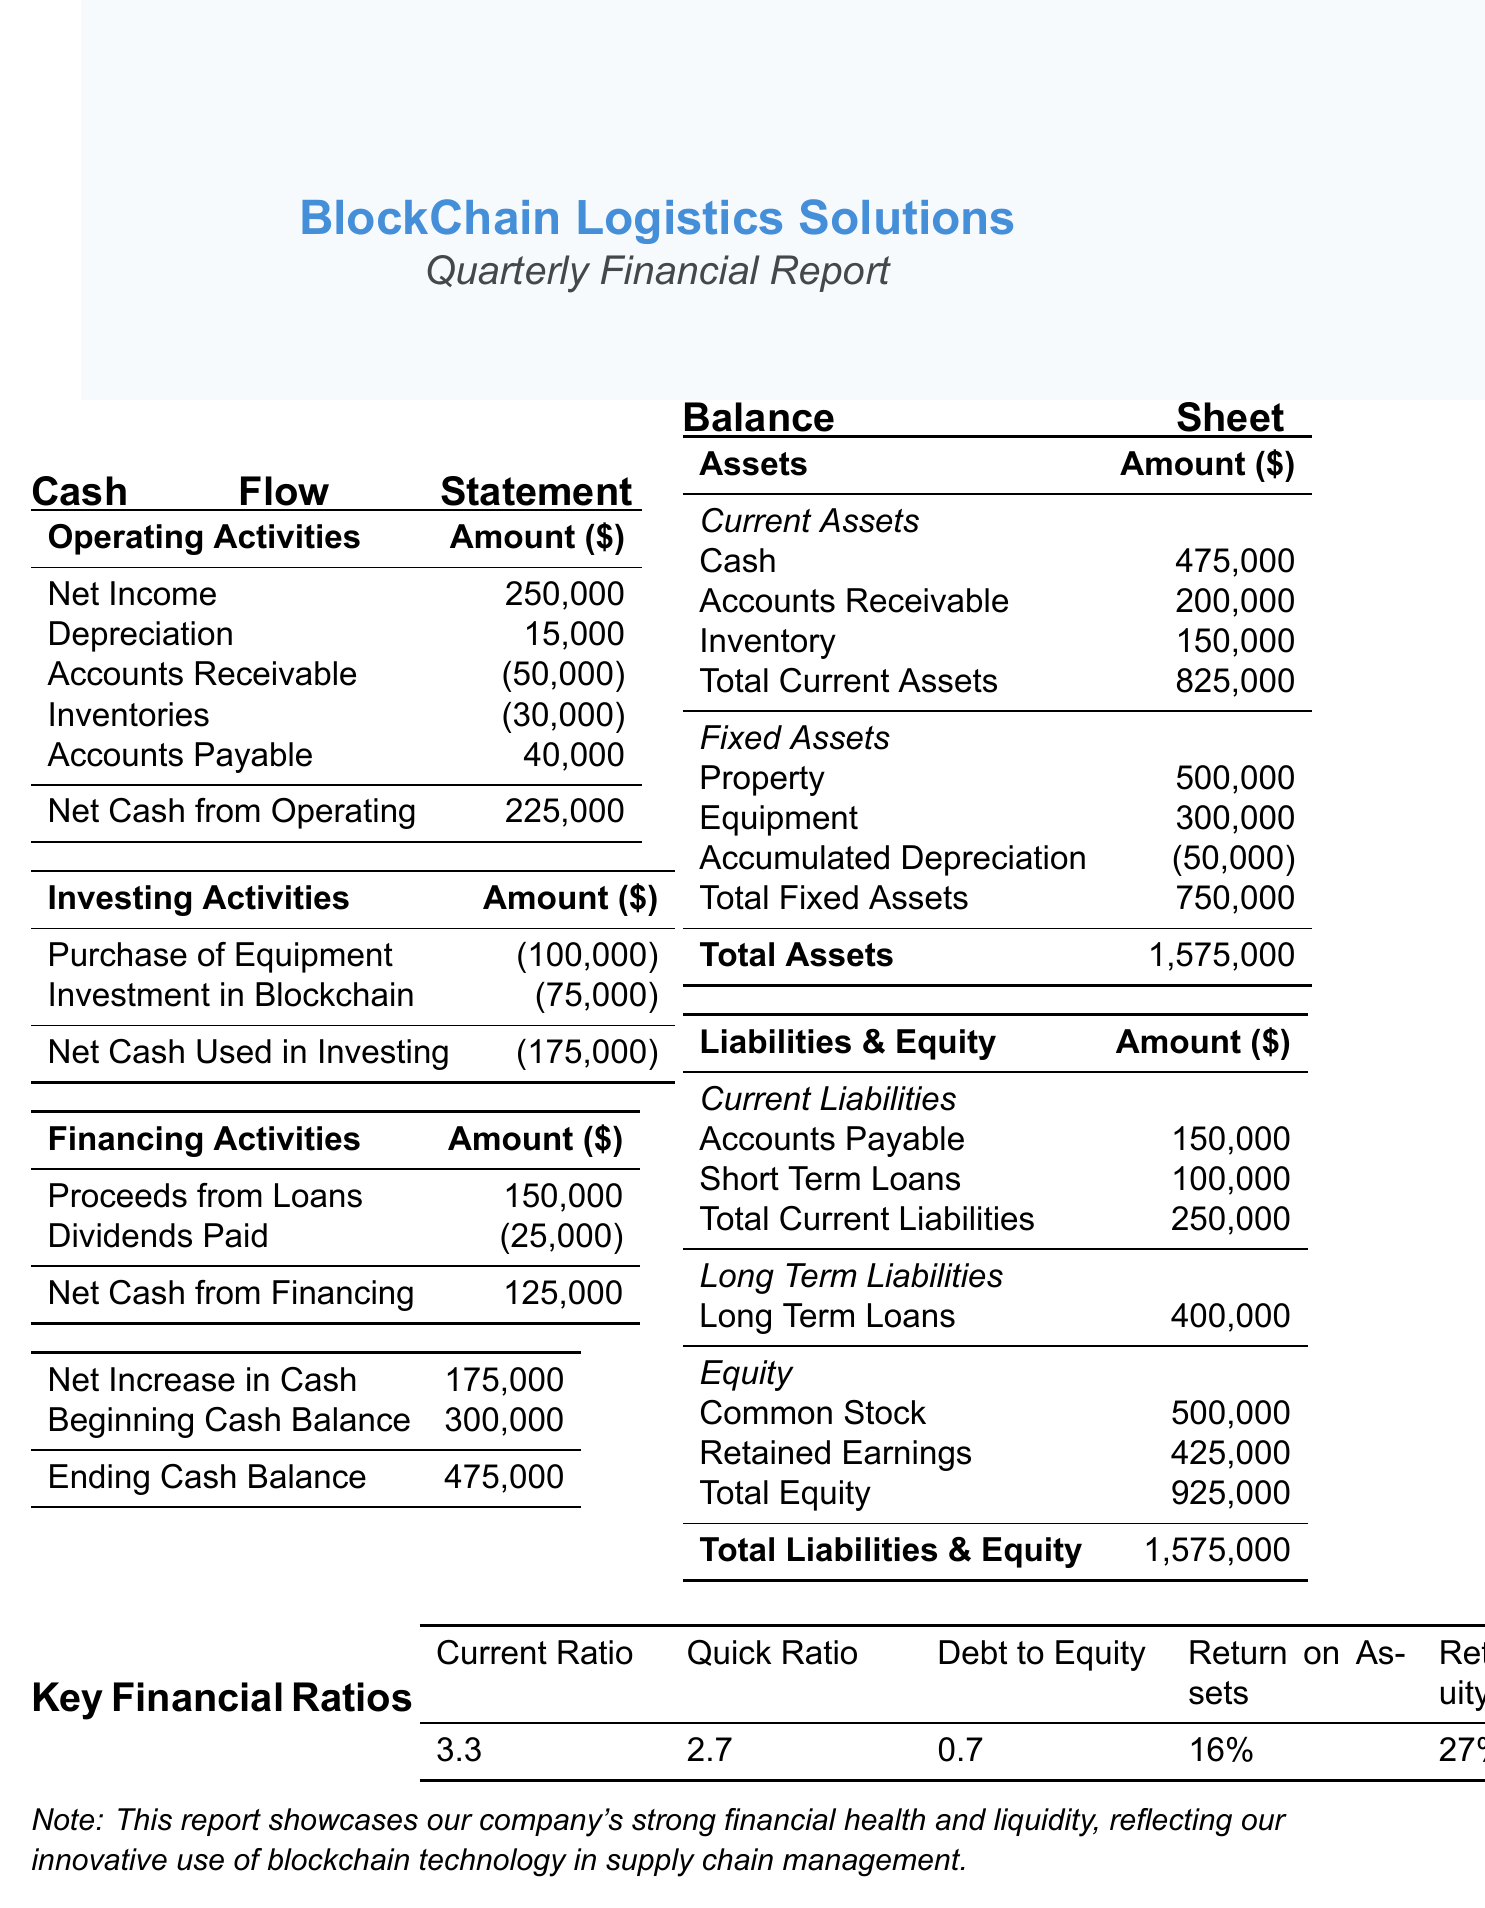What is the net cash from operating activities? The net cash from operating activities is shown in the cash flow statement and is calculated based on net income and adjustments for accounts receivable, inventories, and accounts payable.
Answer: 225,000 What is the total current assets? The total current assets are the sum of cash, accounts receivable, and inventory listed in the balance sheet under assets.
Answer: 825,000 What is the amount of investment in blockchain technology? This amount is specified in the cash flow statement under investing activities and represents the company's investment in blockchain-related assets.
Answer: 75,000 What is the debt to equity ratio? The debt to equity ratio is a key financial ratio that compares total liabilities to total equity, providing insight into the company’s financial leverage.
Answer: 0.7 What is the ending cash balance? The ending cash balance is the final amount of cash on hand after considering the net increase in cash and the beginning cash balance from the cash flow statement.
Answer: 475,000 What is the total equity? Total equity is listed in the balance sheet and reflects the ownership interest held by shareholders in the company.
Answer: 925,000 What is the net cash used in investing activities? This figure is located in the investing activities section and shows the total cash outflows related to investments made by the company.
Answer: -175,000 What are the current liabilities? Current liabilities are the obligations that the company needs to settle within the operating cycle or within a year, found in the liabilities section of the balance sheet.
Answer: 250,000 What is the return on assets? The return on assets ratio indicates how efficiently assets are being used to generate profits, and it is presented as a percentage in the financial ratios.
Answer: 16% 